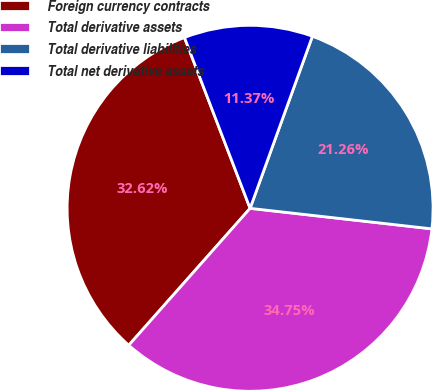Convert chart. <chart><loc_0><loc_0><loc_500><loc_500><pie_chart><fcel>Foreign currency contracts<fcel>Total derivative assets<fcel>Total derivative liabilities<fcel>Total net derivative assets<nl><fcel>32.62%<fcel>34.75%<fcel>21.26%<fcel>11.37%<nl></chart> 